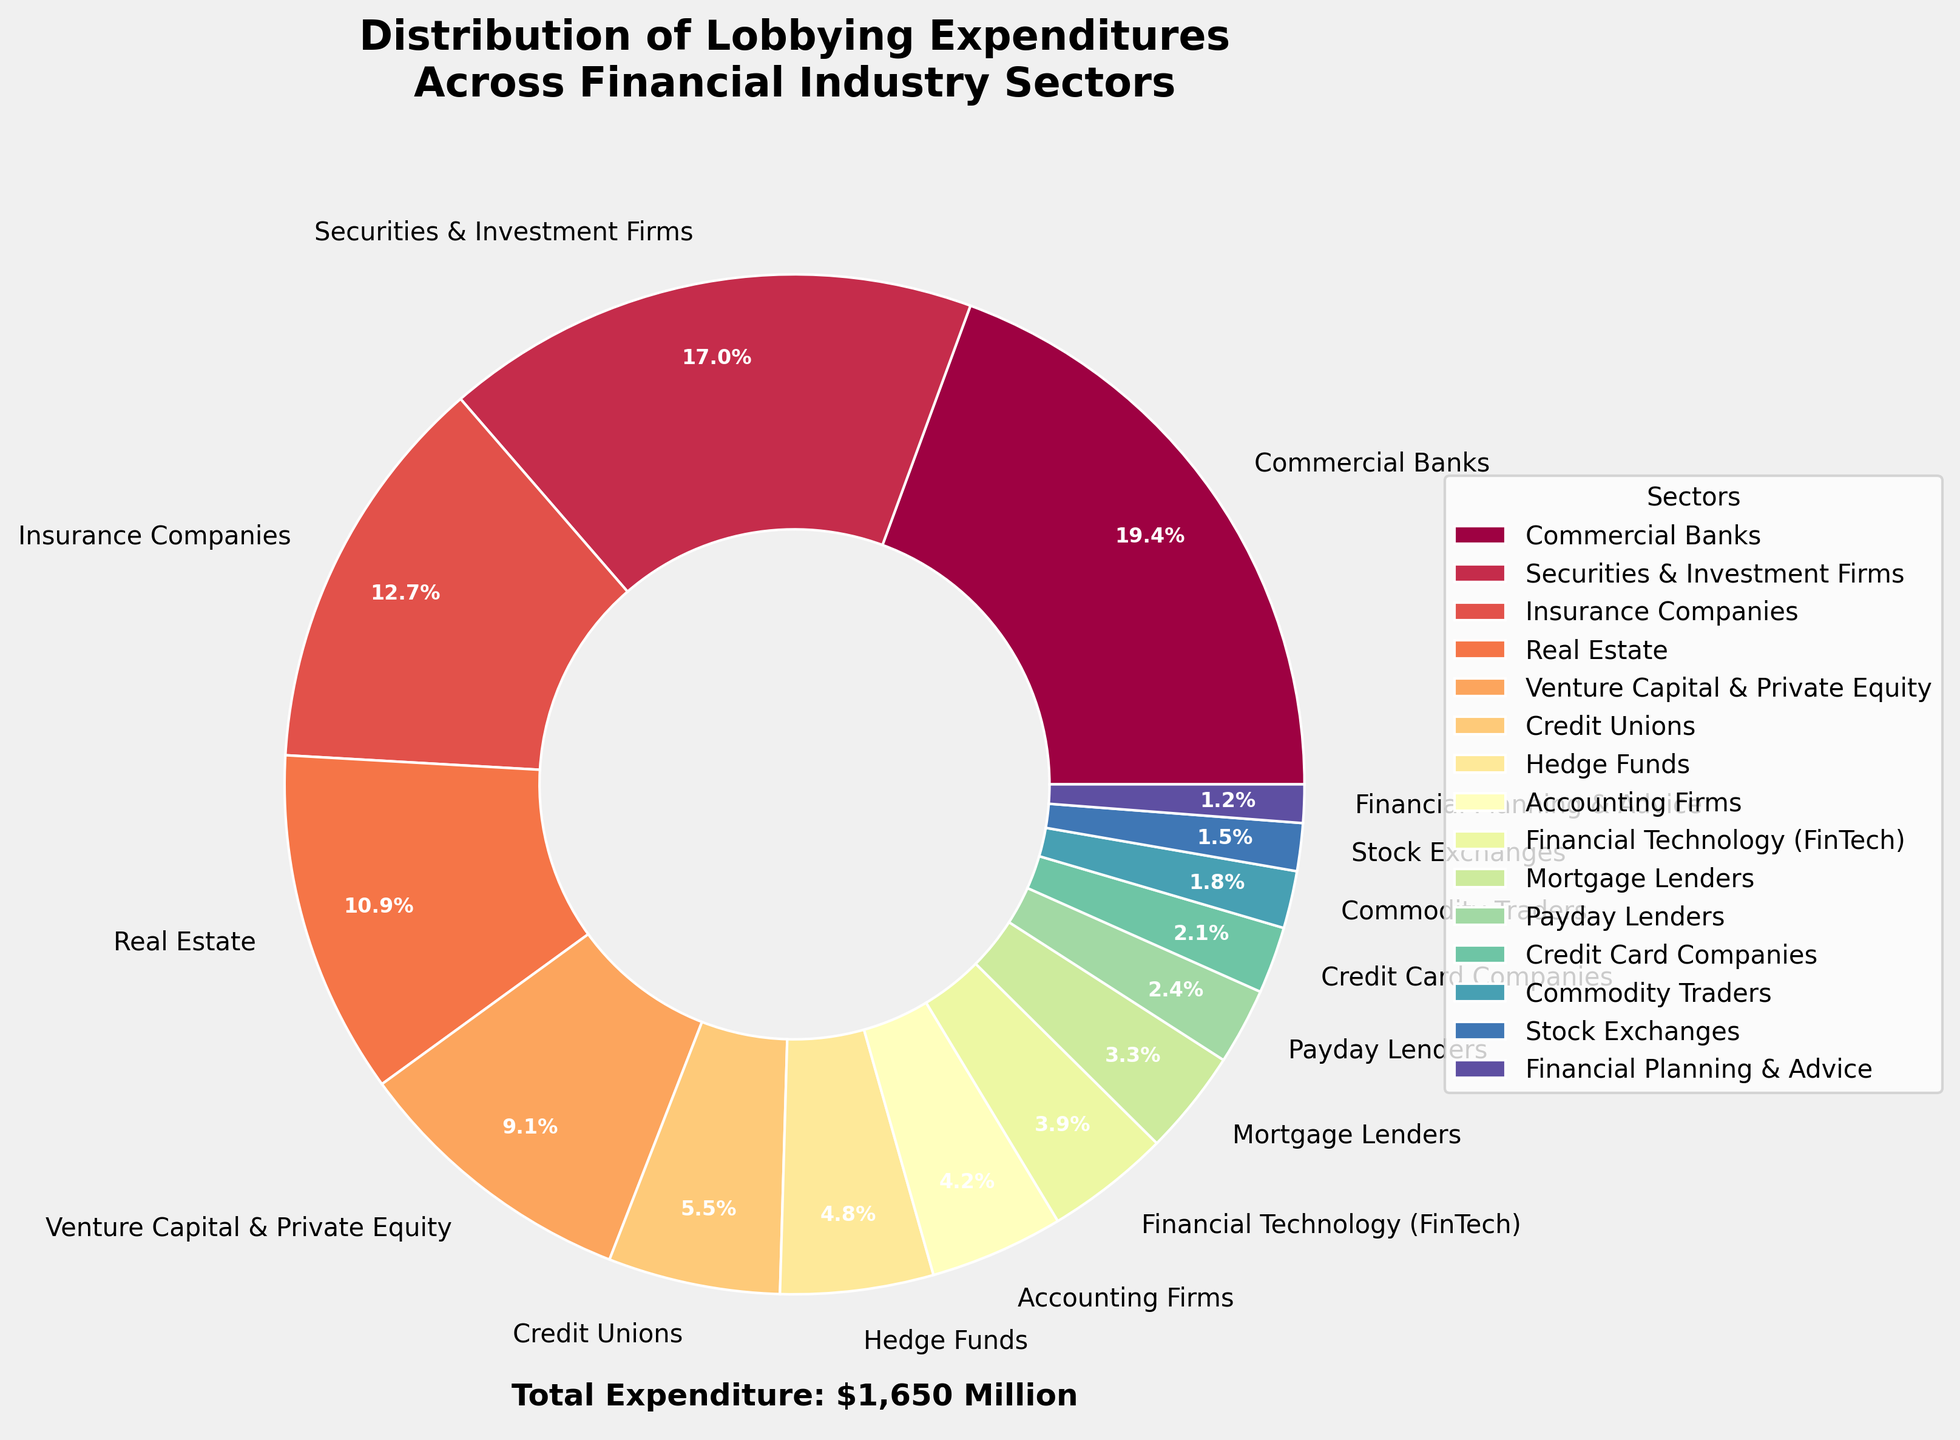What's the largest expenditure sector in the figure? The sector with the highest expenditure is represented with the largest slice in the pie chart, which is Commercial Banks
Answer: Commercial Banks Which sector has higher expenditures, Insurance Companies or Real Estate? Compare the size of the slices for Insurance Companies and Real Estate. Insurance Companies have a larger slice, indicating higher expenditures
Answer: Insurance Companies What is the total expenditure of the three smallest sectors? Identify the three smallest slices in the pie chart which are Commodity Traders, Stock Exchanges, and Financial Planning & Advice, then sum their expenditures (30 + 25 + 20 = 75)
Answer: 75 Million USD What is the combined percentage of expenditures for Securities & Investment Firms and Commercial Banks? Find the percentage values for both sectors from the pie chart and add them together (40.1% + 20.5% = 60.6%)
Answer: 60.6% How do the expenditures of Hedge Funds compare to those of Credit Unions? Compare the sizes of the slices for Hedge Funds and Credit Unions. Hedge Funds have a smaller slice compared to Credit Unions
Answer: Smaller What sectors have expenditures between 50 and 100 million USD? Identify the slices whose labels show expenditures within this range. The sectors are Credit Unions, Hedge Funds, Accounting Firms, Financial Technology (FinTech), and Mortgage Lenders
Answer: Credit Unions, Hedge Funds, Accounting Firms, FinTech, Mortgage Lenders Which sector has almost equal expenditure to the total of Credit Card Companies and Payday Lenders? Sum the expenditures of Credit Card Companies and Payday Lenders (35 + 40 = 75), which is close to Accounting Firms (70) given the rounding
Answer: Accounting Firms If the expenditures of Real Estate and Venture Capital & Private Equity were combined, would they exceed that of Commercial Banks? Sum the expenditures for Real Estate and VC & PE (180 + 150 = 330), which is greater than that of Commercial Banks (320)
Answer: Yes Which sector's expenditure is closest to 10% of the total expenditure? Calculate 10% of the total expenditure (1450 * 0.10 = 145). Identify the sector closest to this value, which is Venture Capital & Private Equity at 150
Answer: Venture Capital & Private Equity How does the visual appearance of the slice representing Commodity Traders differ from Commercial Banks? The slice for Commodity Traders is significantly smaller and takes up a narrow segment, whereas Commercial Banks occupy one of the largest and widest segments of the pie chart
Answer: Smaller, narrower segment 